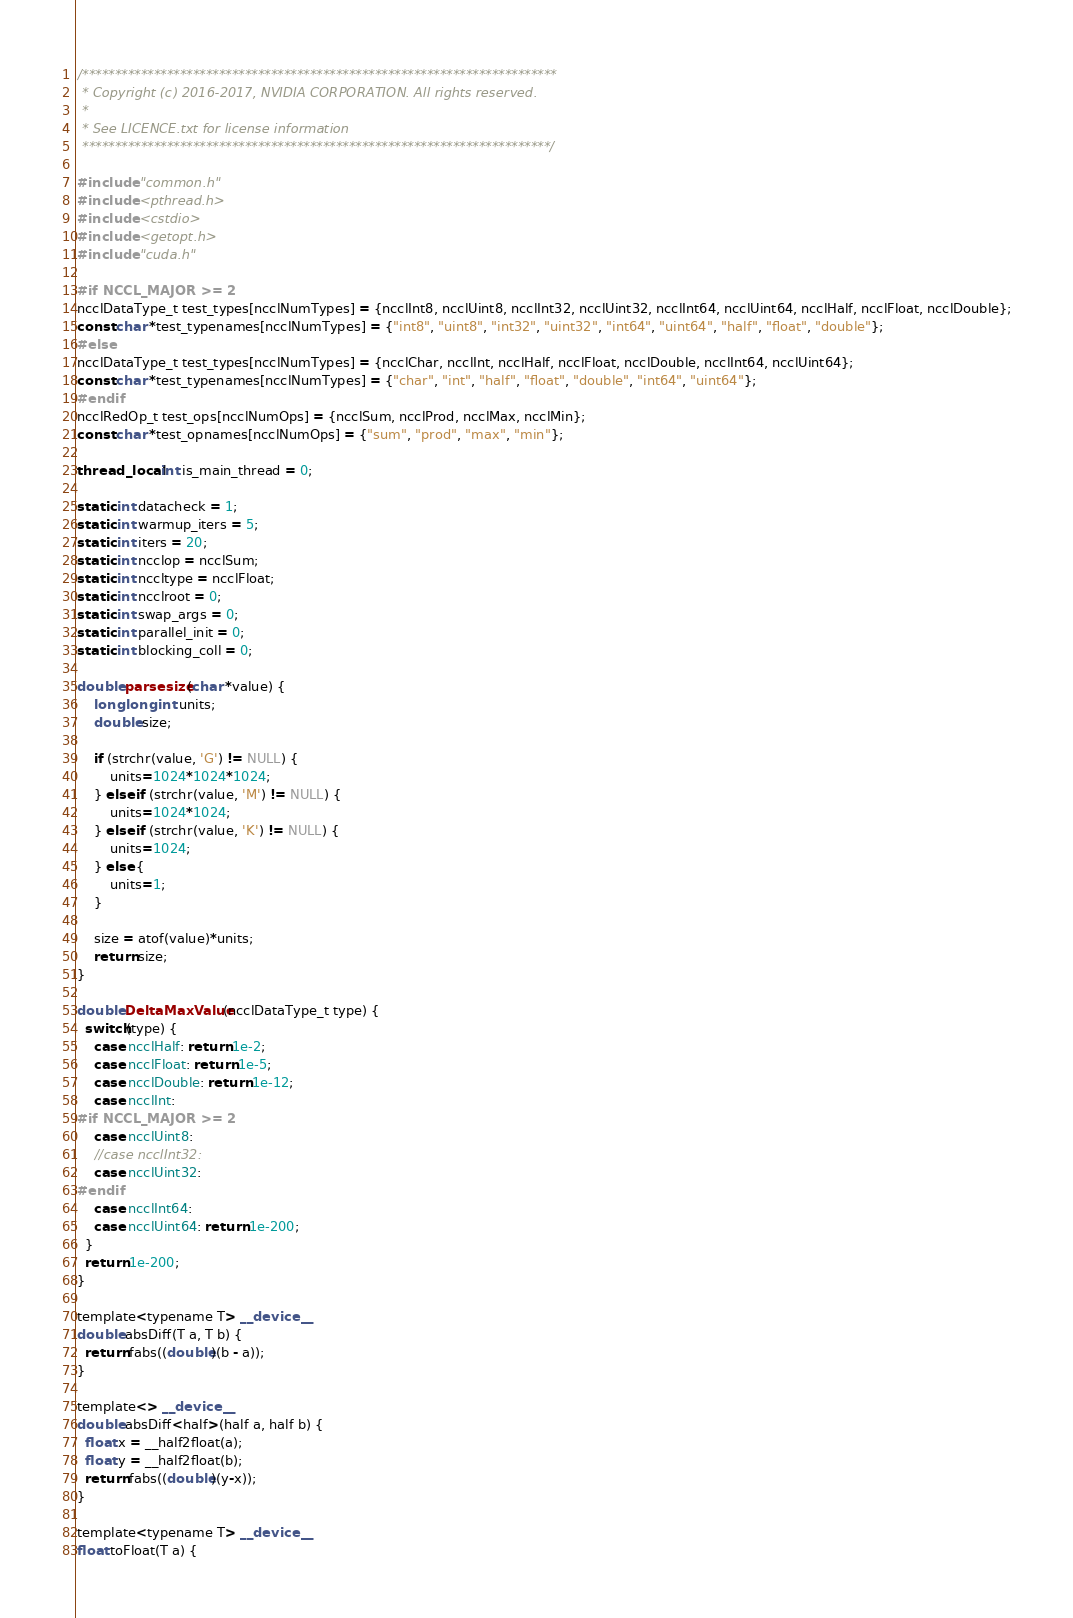Convert code to text. <code><loc_0><loc_0><loc_500><loc_500><_Cuda_>/*************************************************************************
 * Copyright (c) 2016-2017, NVIDIA CORPORATION. All rights reserved.
 *
 * See LICENCE.txt for license information
 ************************************************************************/

#include "common.h"
#include <pthread.h>
#include <cstdio>
#include <getopt.h>
#include "cuda.h"

#if NCCL_MAJOR >= 2
ncclDataType_t test_types[ncclNumTypes] = {ncclInt8, ncclUint8, ncclInt32, ncclUint32, ncclInt64, ncclUint64, ncclHalf, ncclFloat, ncclDouble};
const char *test_typenames[ncclNumTypes] = {"int8", "uint8", "int32", "uint32", "int64", "uint64", "half", "float", "double"};
#else
ncclDataType_t test_types[ncclNumTypes] = {ncclChar, ncclInt, ncclHalf, ncclFloat, ncclDouble, ncclInt64, ncclUint64};
const char *test_typenames[ncclNumTypes] = {"char", "int", "half", "float", "double", "int64", "uint64"};
#endif
ncclRedOp_t test_ops[ncclNumOps] = {ncclSum, ncclProd, ncclMax, ncclMin};
const char *test_opnames[ncclNumOps] = {"sum", "prod", "max", "min"};

thread_local int is_main_thread = 0;

static int datacheck = 1;
static int warmup_iters = 5;
static int iters = 20;
static int ncclop = ncclSum;
static int nccltype = ncclFloat;
static int ncclroot = 0;
static int swap_args = 0;
static int parallel_init = 0;
static int blocking_coll = 0;

double parsesize(char *value) {
    long long int units;
    double size;

    if (strchr(value, 'G') != NULL) {
        units=1024*1024*1024;
    } else if (strchr(value, 'M') != NULL) {
        units=1024*1024;
    } else if (strchr(value, 'K') != NULL) {
        units=1024;
    } else {
        units=1;
    }

    size = atof(value)*units;
    return size;
}

double DeltaMaxValue(ncclDataType_t type) {
  switch(type) {
    case ncclHalf: return 1e-2;
    case ncclFloat: return 1e-5;
    case ncclDouble: return 1e-12;
    case ncclInt:
#if NCCL_MAJOR >= 2
    case ncclUint8:
    //case ncclInt32:
    case ncclUint32:
#endif
    case ncclInt64:
    case ncclUint64: return 1e-200;
  }
  return 1e-200;
}

template<typename T> __device__
double absDiff(T a, T b) {
  return fabs((double)(b - a));
}

template<> __device__
double absDiff<half>(half a, half b) {
  float x = __half2float(a);
  float y = __half2float(b);
  return fabs((double)(y-x));
}

template<typename T> __device__
float toFloat(T a) {</code> 